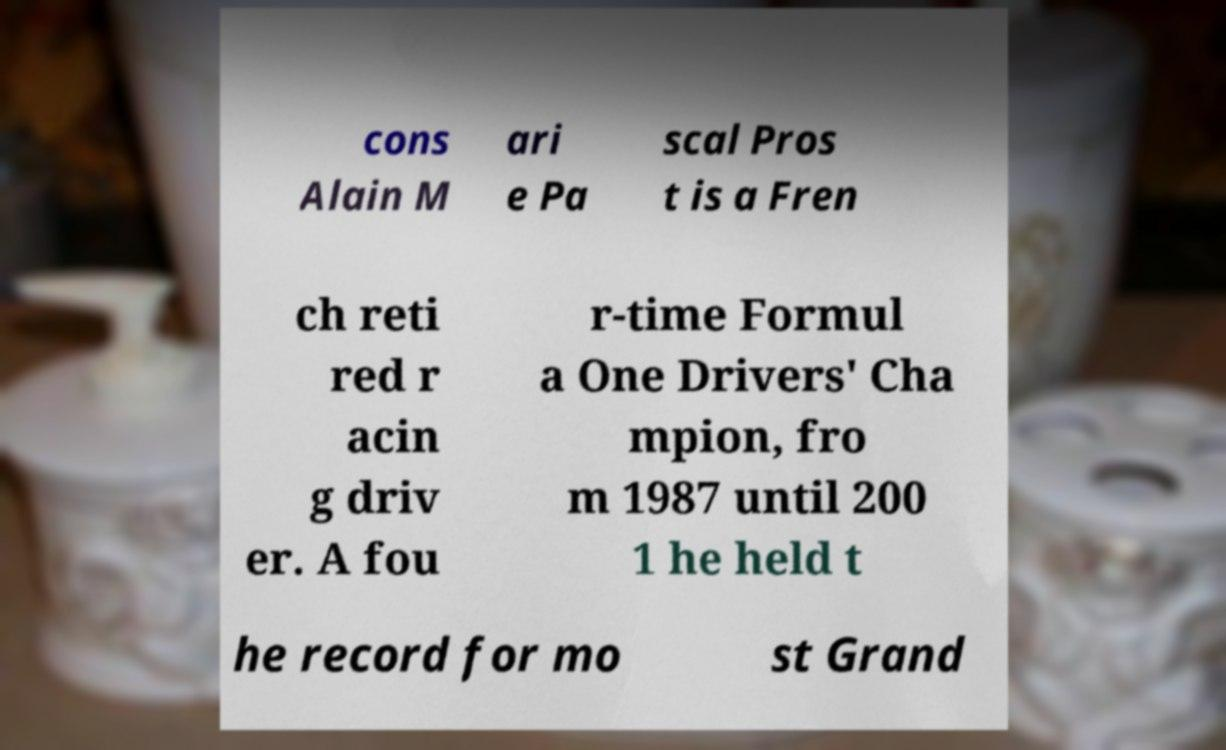I need the written content from this picture converted into text. Can you do that? cons Alain M ari e Pa scal Pros t is a Fren ch reti red r acin g driv er. A fou r-time Formul a One Drivers' Cha mpion, fro m 1987 until 200 1 he held t he record for mo st Grand 